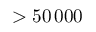<formula> <loc_0><loc_0><loc_500><loc_500>> 5 0 \, 0 0 0</formula> 